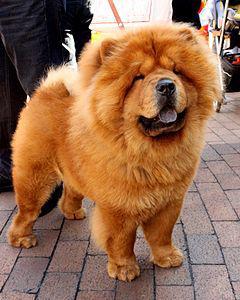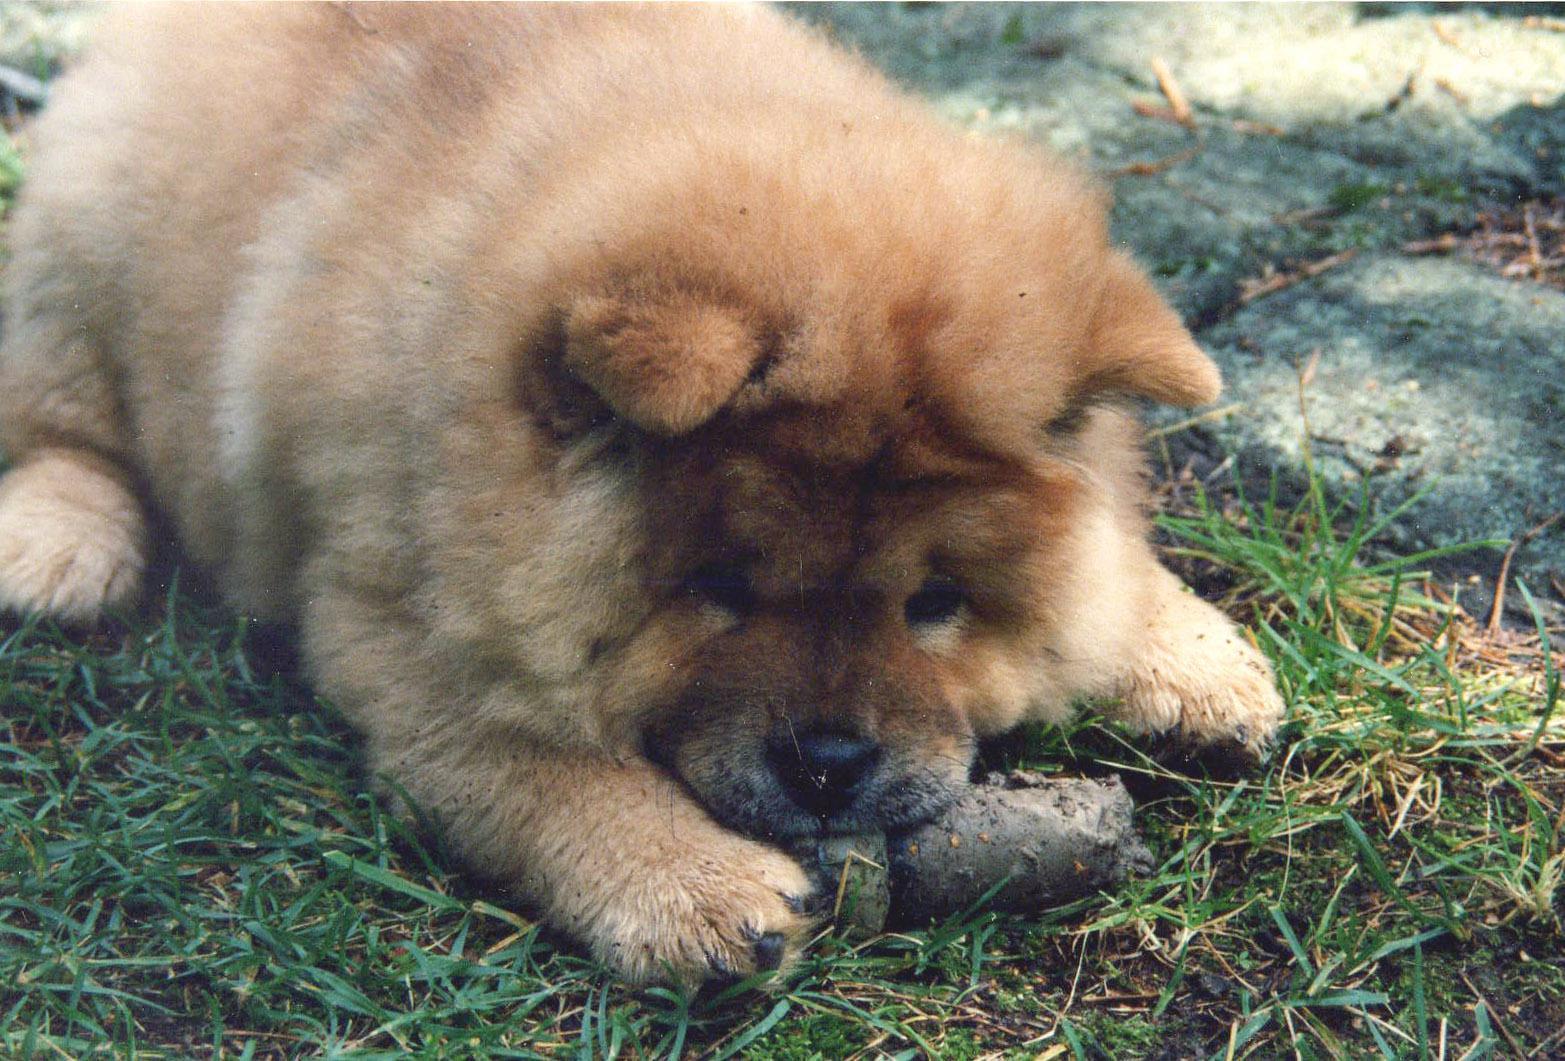The first image is the image on the left, the second image is the image on the right. Assess this claim about the two images: "At least one of the dogs is being handled by a human; either by leash or by grip.". Correct or not? Answer yes or no. Yes. The first image is the image on the left, the second image is the image on the right. Given the left and right images, does the statement "Exactly one chow dog is standing with all four paws on the ground." hold true? Answer yes or no. Yes. 